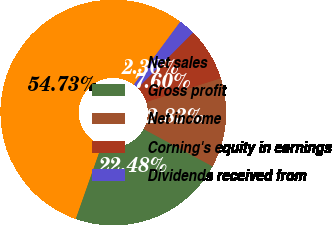<chart> <loc_0><loc_0><loc_500><loc_500><pie_chart><fcel>Net sales<fcel>Gross profit<fcel>Net income<fcel>Corning's equity in earnings<fcel>Dividends received from<nl><fcel>54.73%<fcel>22.48%<fcel>12.83%<fcel>7.6%<fcel>2.36%<nl></chart> 